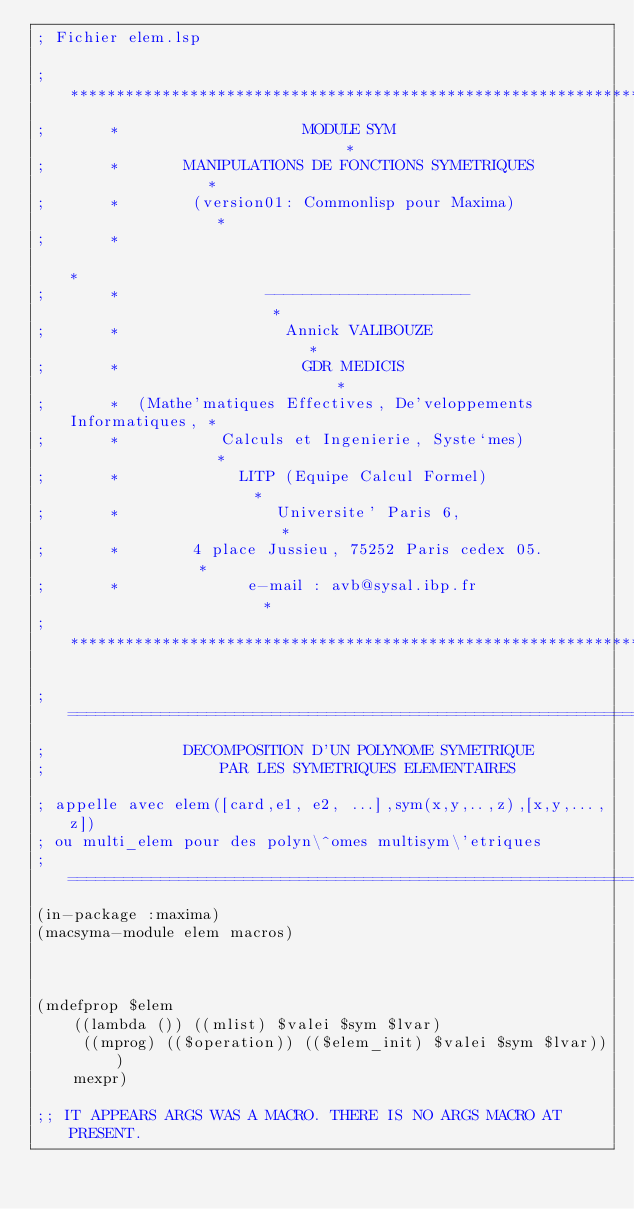Convert code to text. <code><loc_0><loc_0><loc_500><loc_500><_Lisp_>; Fichier elem.lsp

;       ***************************************************************
;       *                    MODULE SYM                               *
;       *       MANIPULATIONS DE FONCTIONS SYMETRIQUES                *
;       *        (version01: Commonlisp pour Maxima)                 *
;       *                                                             *
;       *                ----------------------                       *
;       *                  Annick VALIBOUZE                           *
;       *                    GDR MEDICIS                              *
;       *  (Mathe'matiques Effectives, De'veloppements Informatiques, *
;       *           Calculs et Ingenierie, Syste`mes)                 *
;       *             LITP (Equipe Calcul Formel)                     *
;       *                 Universite' Paris 6,                        *
;       *        4 place Jussieu, 75252 Paris cedex 05.               *
;       *              e-mail : avb@sysal.ibp.fr                      *
;       ***************************************************************

;=============================================================================
;               DECOMPOSITION D'UN POLYNOME SYMETRIQUE
;                   PAR LES SYMETRIQUES ELEMENTAIRES

; appelle avec elem([card,e1, e2, ...],sym(x,y,..,z),[x,y,...,z])
; ou multi_elem pour des polyn\^omes multisym\'etriques
;=============================================================================
(in-package :maxima)
(macsyma-module elem macros)



(mdefprop $elem
    ((lambda ()) ((mlist) $valei $sym $lvar)
     ((mprog) (($operation)) (($elem_init) $valei $sym $lvar)))
    mexpr)

;; IT APPEARS ARGS WAS A MACRO. THERE IS NO ARGS MACRO AT PRESENT.</code> 